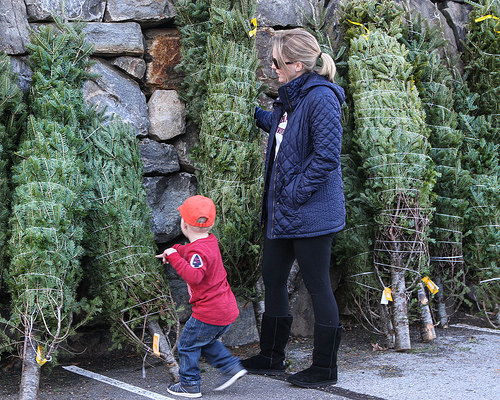<image>
Is the woman to the right of the hat? Yes. From this viewpoint, the woman is positioned to the right side relative to the hat. 